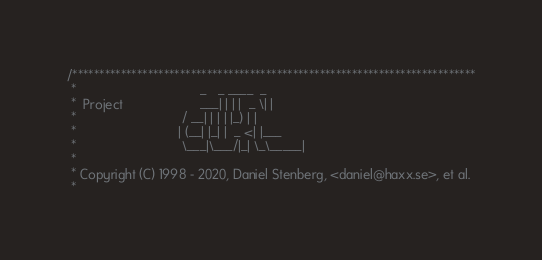Convert code to text. <code><loc_0><loc_0><loc_500><loc_500><_C_>/***************************************************************************
 *                                  _   _ ____  _
 *  Project                     ___| | | |  _ \| |
 *                             / __| | | | |_) | |
 *                            | (__| |_| |  _ <| |___
 *                             \___|\___/|_| \_\_____|
 *
 * Copyright (C) 1998 - 2020, Daniel Stenberg, <daniel@haxx.se>, et al.
 *</code> 